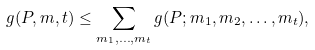Convert formula to latex. <formula><loc_0><loc_0><loc_500><loc_500>g ( P , m , t ) \leq \sum _ { m _ { 1 } , \dots , m _ { t } } g ( P ; m _ { 1 } , m _ { 2 } , \dots , m _ { t } ) ,</formula> 